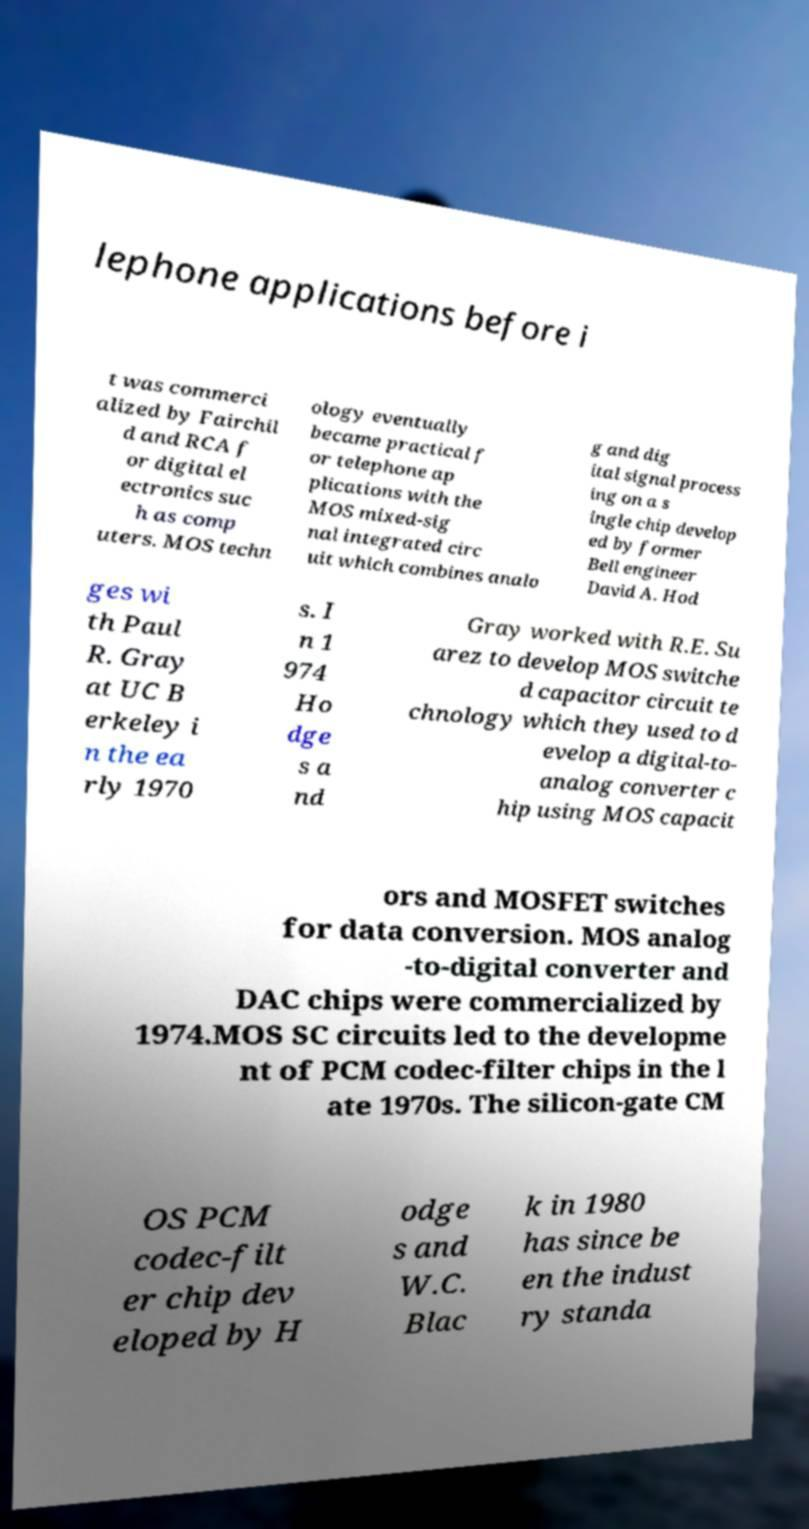Please read and relay the text visible in this image. What does it say? lephone applications before i t was commerci alized by Fairchil d and RCA f or digital el ectronics suc h as comp uters. MOS techn ology eventually became practical f or telephone ap plications with the MOS mixed-sig nal integrated circ uit which combines analo g and dig ital signal process ing on a s ingle chip develop ed by former Bell engineer David A. Hod ges wi th Paul R. Gray at UC B erkeley i n the ea rly 1970 s. I n 1 974 Ho dge s a nd Gray worked with R.E. Su arez to develop MOS switche d capacitor circuit te chnology which they used to d evelop a digital-to- analog converter c hip using MOS capacit ors and MOSFET switches for data conversion. MOS analog -to-digital converter and DAC chips were commercialized by 1974.MOS SC circuits led to the developme nt of PCM codec-filter chips in the l ate 1970s. The silicon-gate CM OS PCM codec-filt er chip dev eloped by H odge s and W.C. Blac k in 1980 has since be en the indust ry standa 